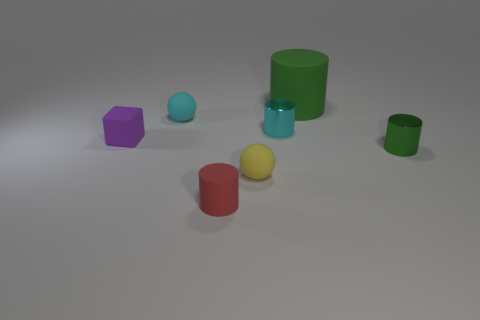Does the small red object have the same material as the large green thing?
Keep it short and to the point. Yes. There is a cyan thing behind the small cyan metal cylinder; are there any cyan matte balls right of it?
Keep it short and to the point. No. Is there a tiny yellow thing that has the same shape as the tiny purple matte object?
Your answer should be very brief. No. Is the color of the large rubber cylinder the same as the tiny block?
Your answer should be compact. No. What is the material of the ball in front of the metallic cylinder on the right side of the cyan metal cylinder?
Make the answer very short. Rubber. What is the size of the green rubber object?
Your response must be concise. Large. There is a purple object that is made of the same material as the yellow ball; what size is it?
Your response must be concise. Small. Is the size of the object that is in front of the yellow rubber thing the same as the green rubber cylinder?
Make the answer very short. No. There is a metal object to the left of the matte object right of the tiny sphere in front of the purple block; what shape is it?
Provide a succinct answer. Cylinder. How many things are tiny cyan metal things or cylinders in front of the green matte thing?
Ensure brevity in your answer.  3. 